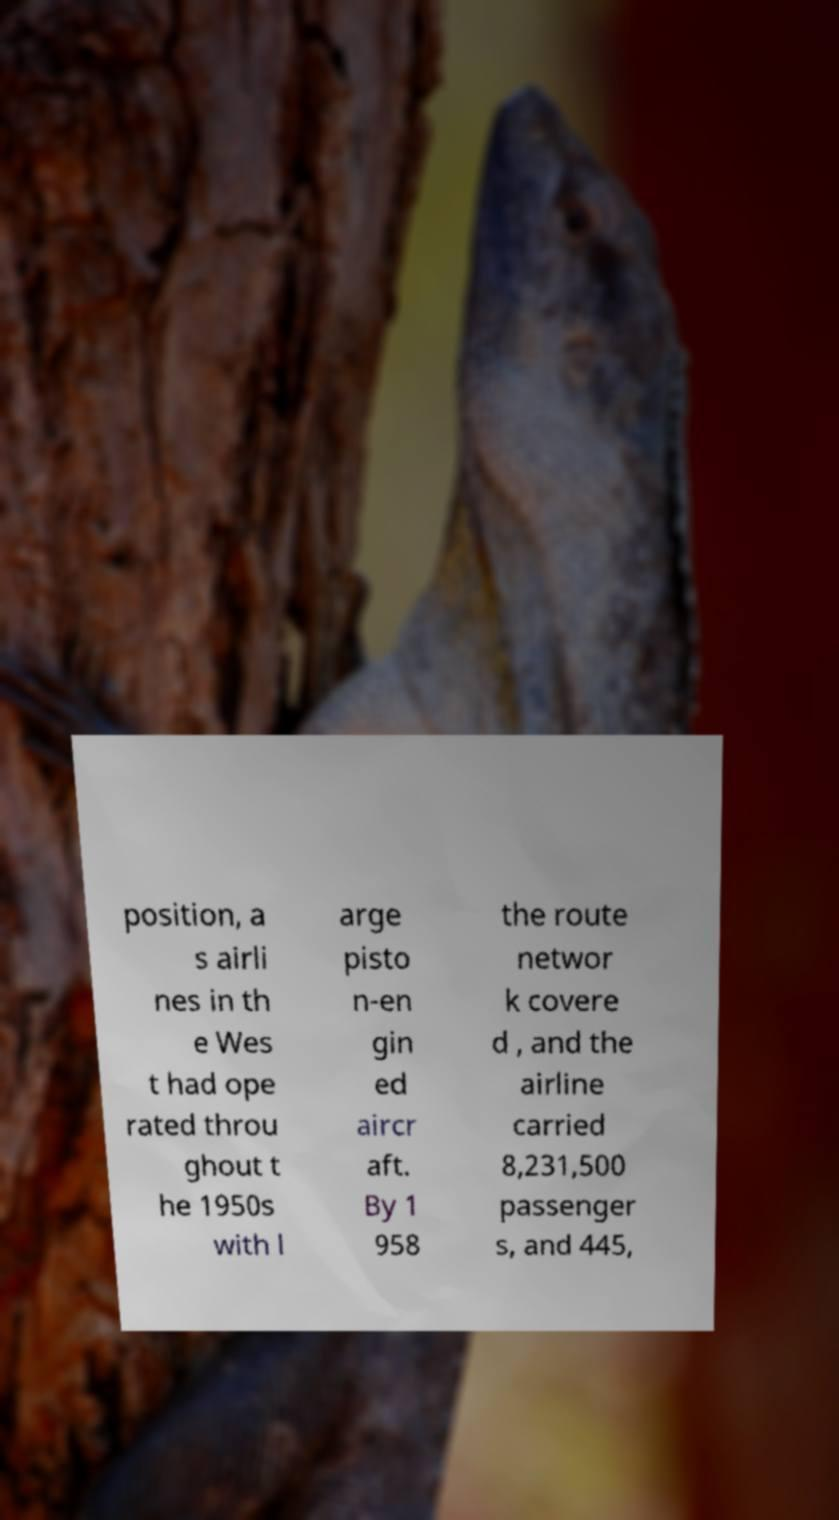Can you read and provide the text displayed in the image?This photo seems to have some interesting text. Can you extract and type it out for me? position, a s airli nes in th e Wes t had ope rated throu ghout t he 1950s with l arge pisto n-en gin ed aircr aft. By 1 958 the route networ k covere d , and the airline carried 8,231,500 passenger s, and 445, 